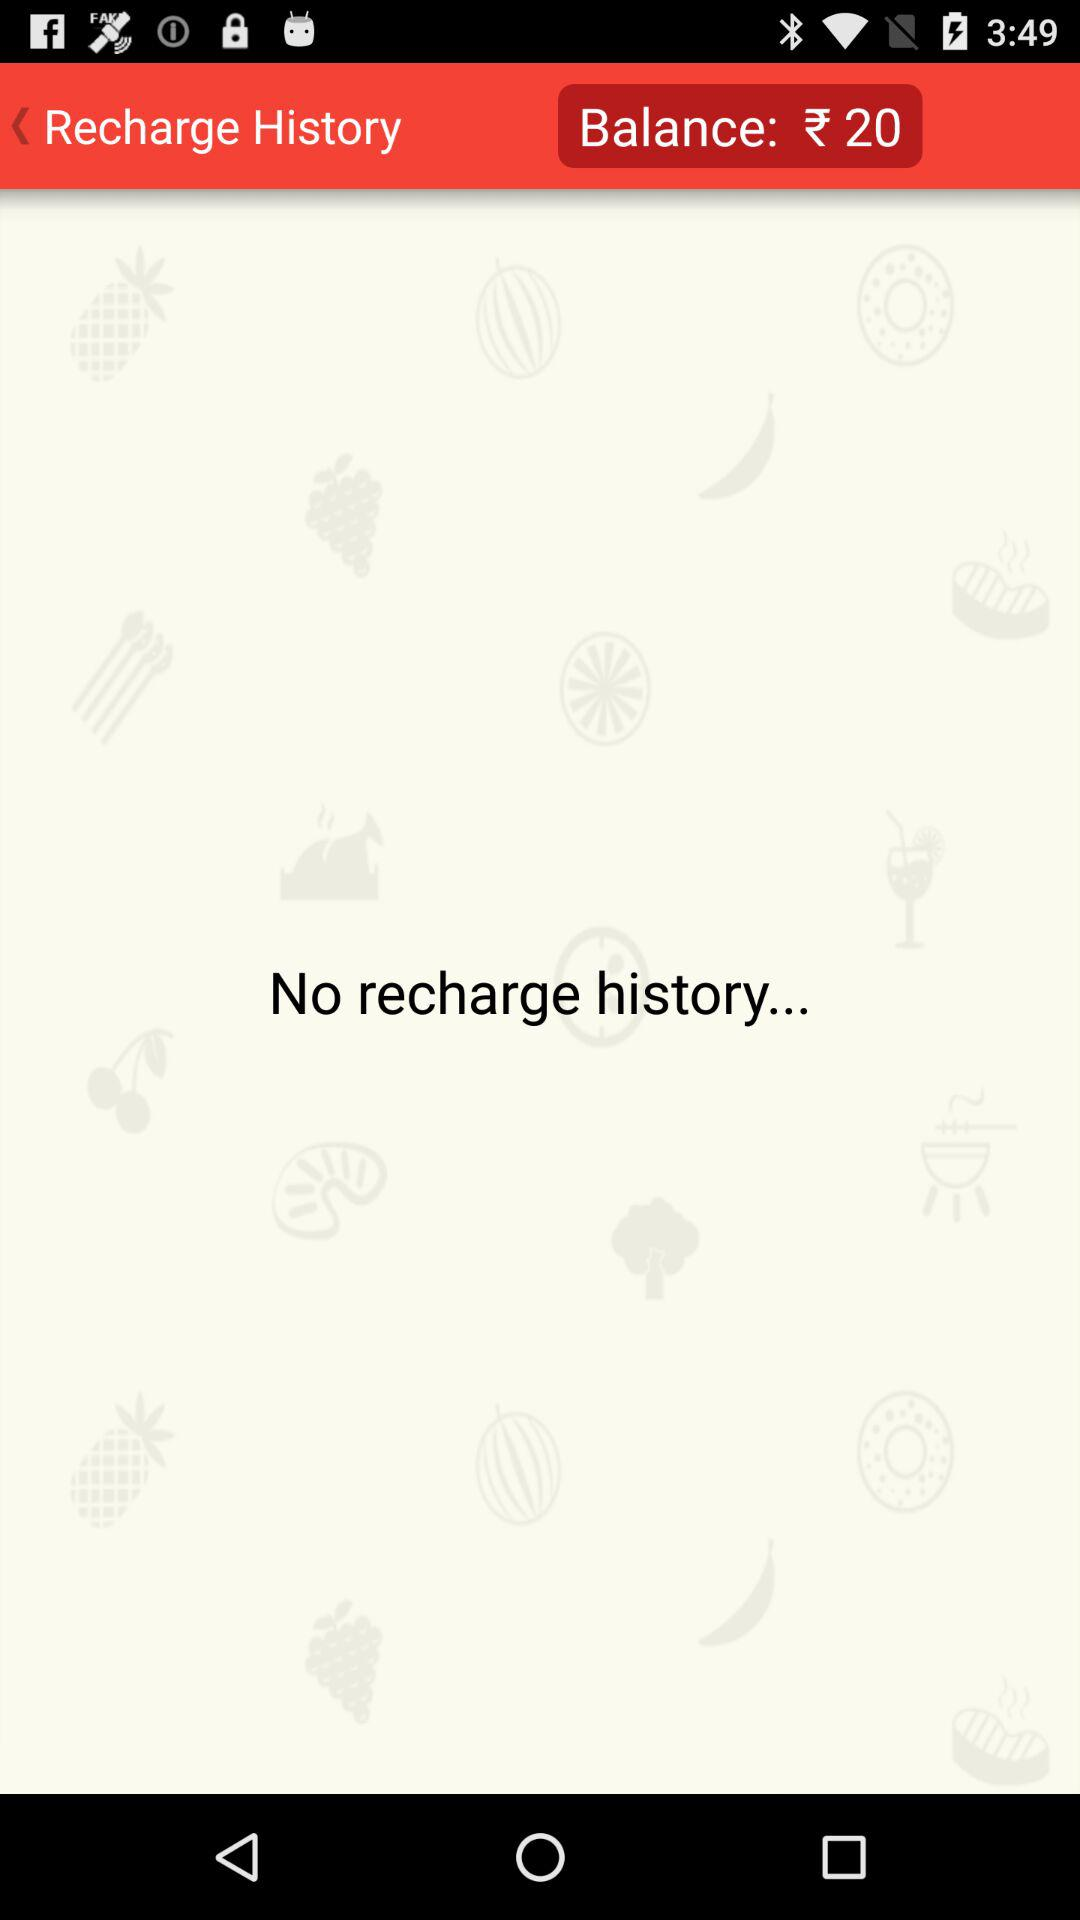What is the balance? The balance is ₹20. 